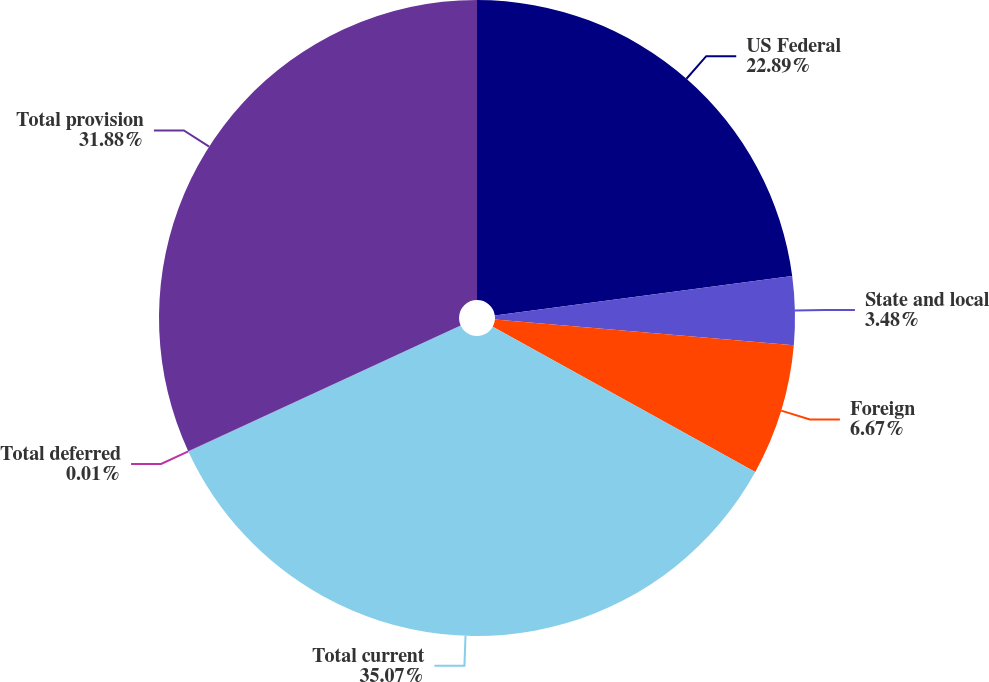Convert chart. <chart><loc_0><loc_0><loc_500><loc_500><pie_chart><fcel>US Federal<fcel>State and local<fcel>Foreign<fcel>Total current<fcel>Total deferred<fcel>Total provision<nl><fcel>22.89%<fcel>3.48%<fcel>6.67%<fcel>35.07%<fcel>0.01%<fcel>31.88%<nl></chart> 